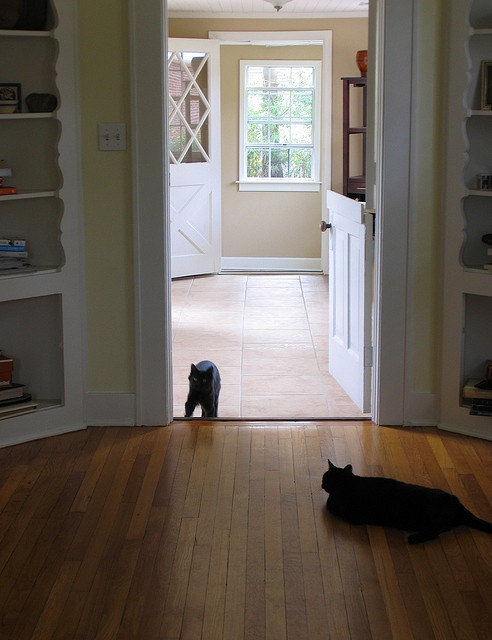Describe the objects in this image and their specific colors. I can see book in black, gray, lavender, and darkgreen tones, cat in black, gray, and maroon tones, cat in black and gray tones, book in black tones, and book in black tones in this image. 